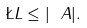<formula> <loc_0><loc_0><loc_500><loc_500>\L L \leq | \ A | .</formula> 